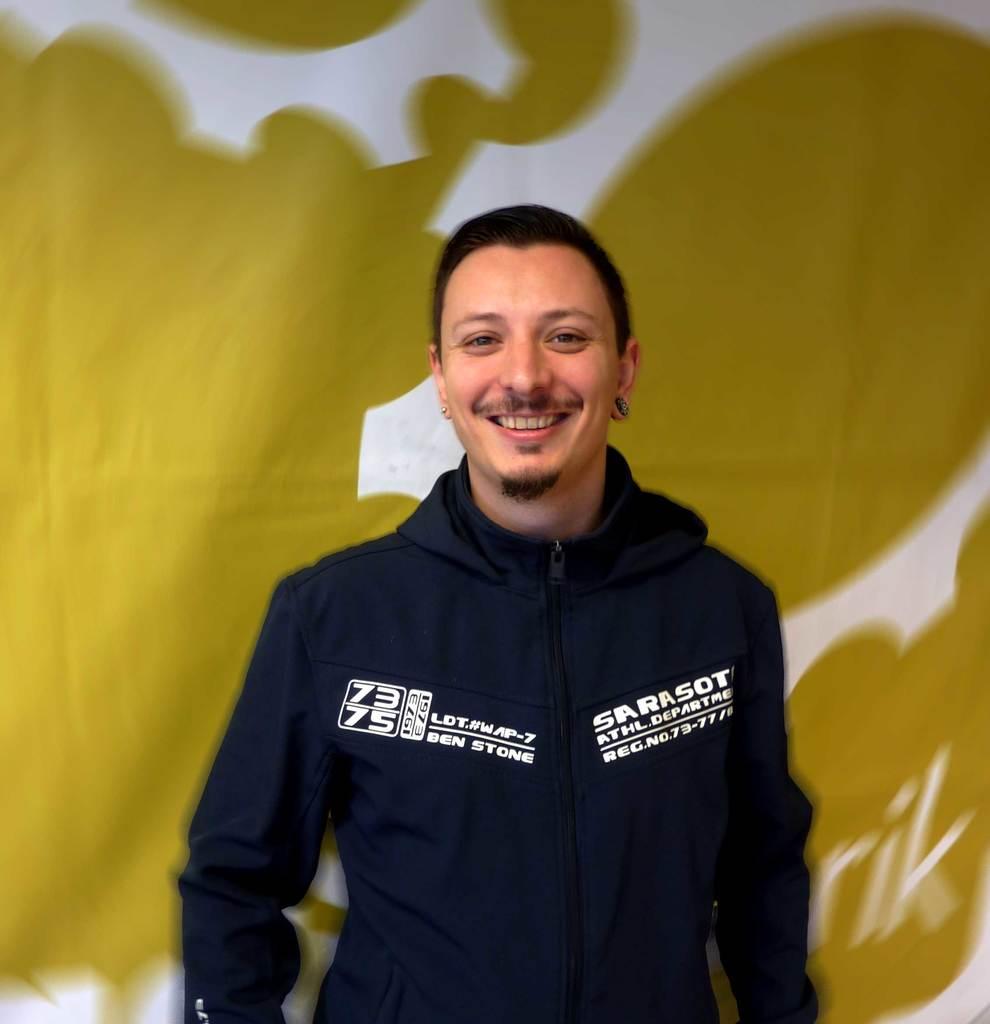What numbers are on this person's jacket?
Your answer should be compact. 73 75. 